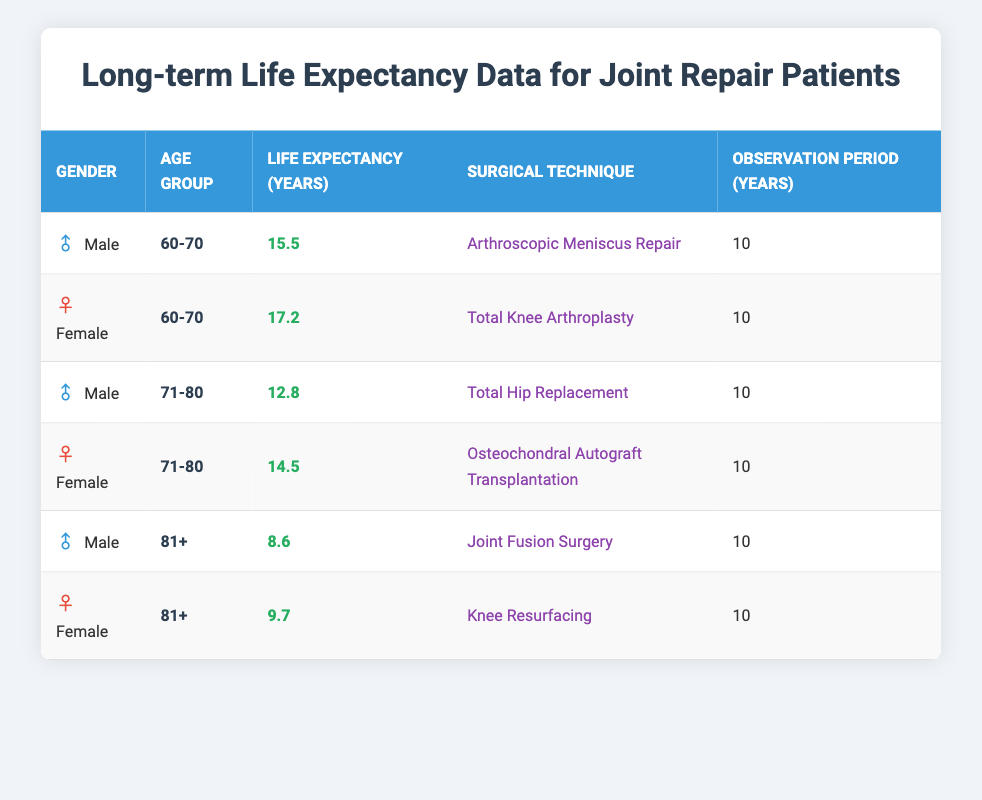What is the life expectancy for males aged 60-70 who had Arthroscopic Meniscus Repair? According to the table, the life expectancy for males in the age group of 60-70 who underwent Arthroscopic Meniscus Repair is 15.5 years.
Answer: 15.5 years What is the life expectancy for females aged 71-80 who had Osteochondral Autograft Transplantation? The table shows that females aged 71-80 who had Osteochondral Autograft Transplantation have a life expectancy of 14.5 years.
Answer: 14.5 years Which surgical technique has the highest life expectancy for the age group 60-70? For males aged 60-70, the life expectancy after Arthroscopic Meniscus Repair is 15.5 years, and for females aged 60-70 undergoing Total Knee Arthroplasty, it is 17.2 years. Since 17.2 years is higher than 15.5 years, Total Knee Arthroplasty has the highest life expectancy in this category.
Answer: Total Knee Arthroplasty What is the difference in life expectancy between males aged 81+ and females aged 81+? Males aged 81+ have a life expectancy of 8.6 years, while females in the same age group have a life expectancy of 9.7 years. The difference is 9.7 - 8.6 = 1.1 years.
Answer: 1.1 years Is the life expectancy for males aged 71-80 greater than for females aged 60-70? Males aged 71-80 have a life expectancy of 12.8 years, while females aged 60-70 have a life expectancy of 17.2 years. Since 12.8 is less than 17.2, the statement is false.
Answer: No What is the average life expectancy for the age group 81+ across both genders? The life expectancy for males aged 81+ is 8.6 years, and for females aged 81+, it is 9.7 years. To find the average, we sum these values: 8.6 + 9.7 = 18.3 years, and then divide by 2, so the average is 18.3 / 2 = 9.15 years.
Answer: 9.15 years Does the observation period for all entries in the table equal 10 years? According to the table, the observation period for each entry is consistently listed as 10 years. Therefore, the statement is true.
Answer: Yes Which gender had a higher life expectancy in the age group 60-70? The life expectancy for females aged 60-70 is 17.2 years, while for males in the same age group is 15.5 years. Thus, females had the higher life expectancy.
Answer: Female 